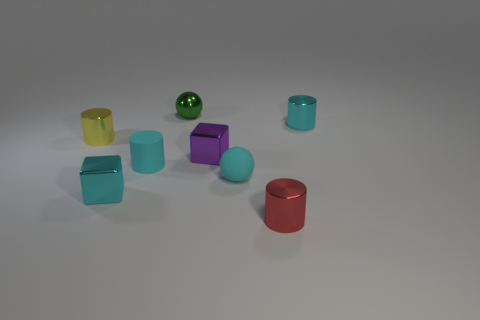What number of green metal things have the same size as the purple metallic thing?
Your answer should be very brief. 1. What color is the tiny cylinder that is left of the tiny cyan cylinder that is in front of the yellow metal cylinder?
Provide a short and direct response. Yellow. Are any small gray metal balls visible?
Your answer should be compact. No. Is the purple thing the same shape as the small red object?
Give a very brief answer. No. There is a small yellow cylinder behind the cyan cube; how many tiny cyan things are behind it?
Ensure brevity in your answer.  1. How many tiny metallic things are in front of the metal sphere and to the left of the purple shiny cube?
Offer a very short reply. 2. How many objects are either tiny blue spheres or small metallic cylinders behind the cyan matte cylinder?
Provide a succinct answer. 2. What is the size of the purple block that is the same material as the green ball?
Provide a short and direct response. Small. What shape is the purple shiny thing that is to the right of the tiny cyan metal thing in front of the cyan rubber ball?
Keep it short and to the point. Cube. What number of purple objects are shiny objects or tiny shiny spheres?
Give a very brief answer. 1. 